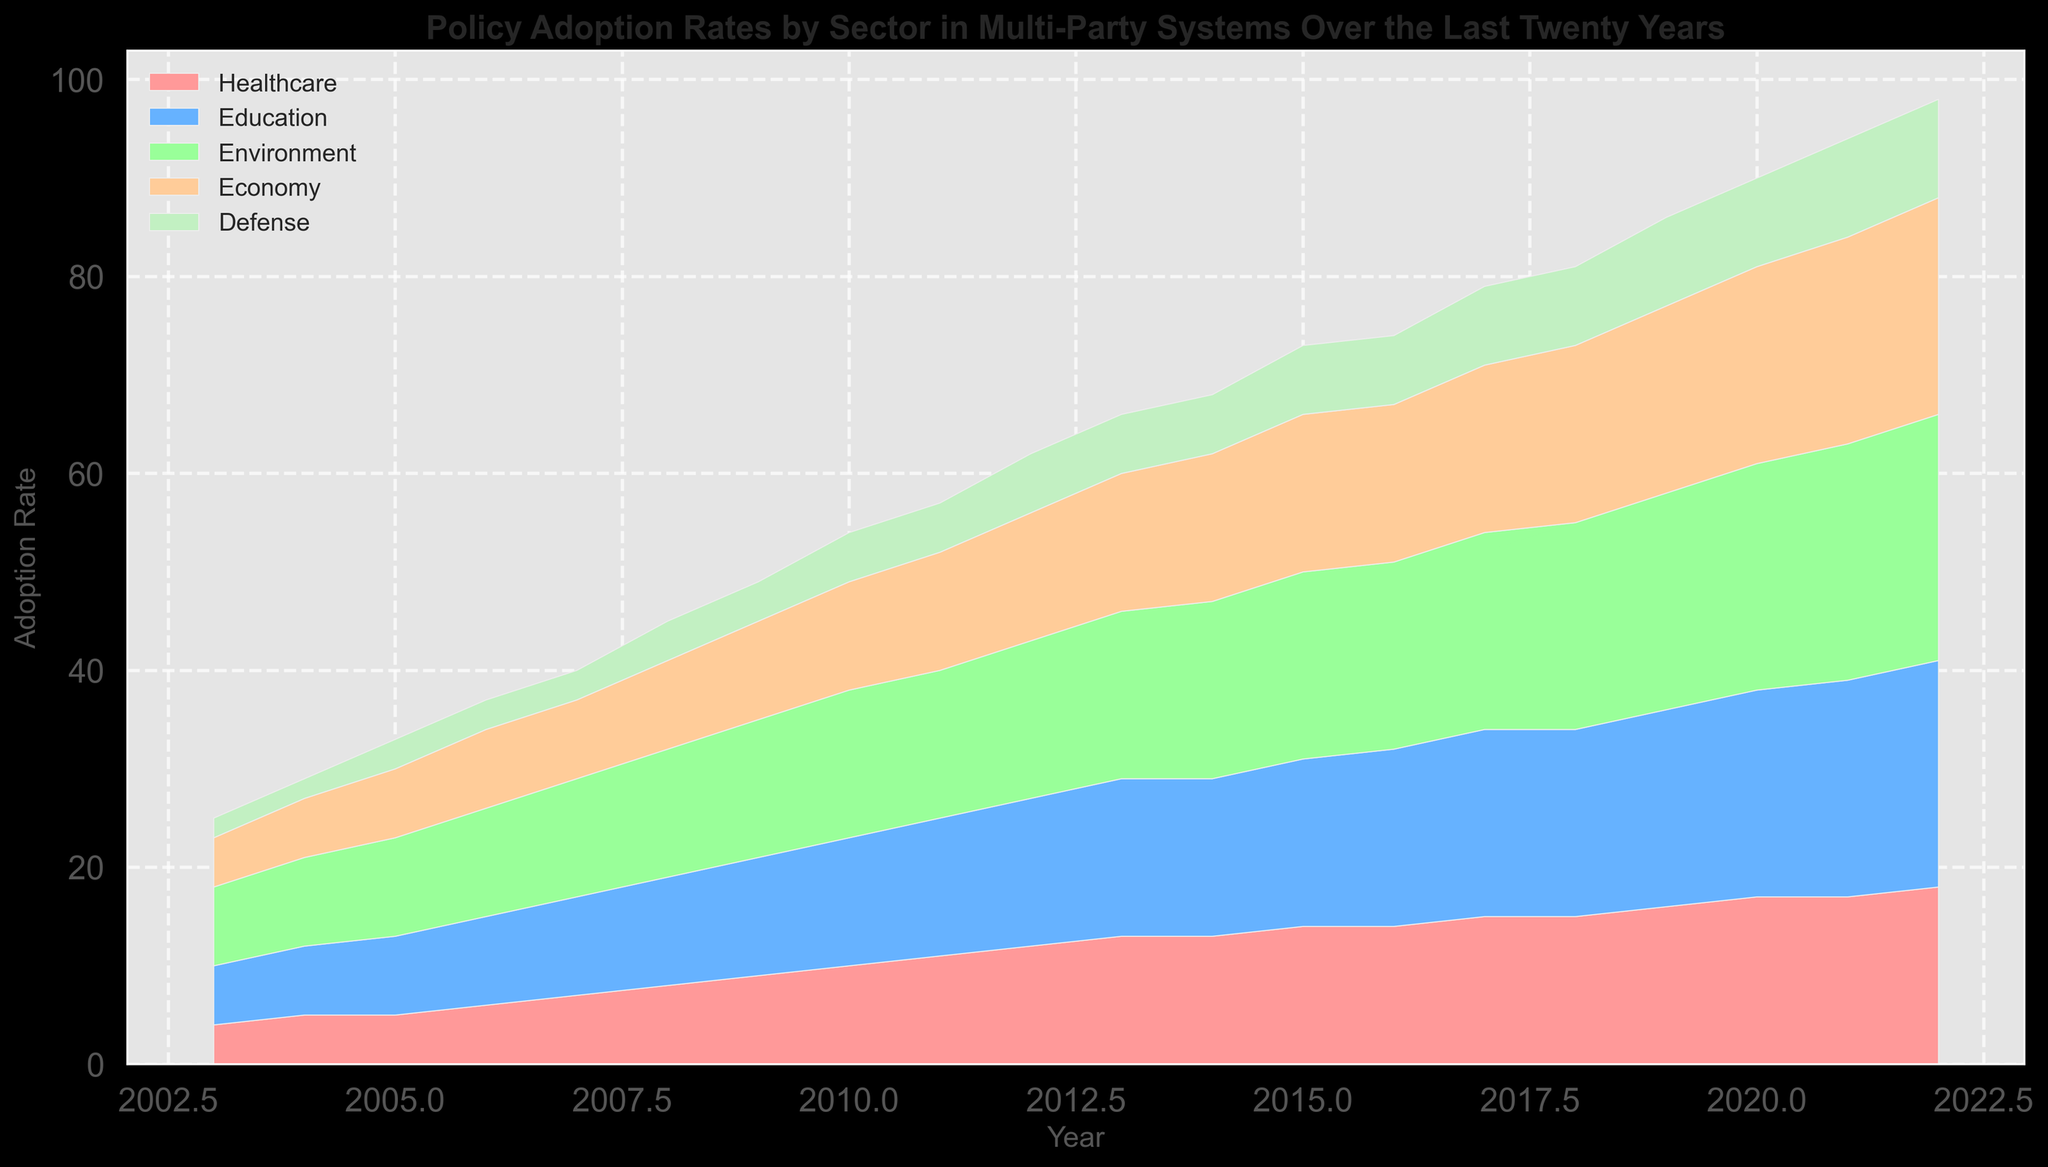What is the trend in policy adoption rates for the Healthcare sector over the last twenty years? By observing the area chart from 2003 to 2022, the adoption rate in the Healthcare sector shows a steady increase every year, starting from 4 and reaching 18 in 2022.
Answer: Steady increase Which sector had the highest adoption rate in 2018? By looking at the heights of the stacked areas for the year 2018, the topmost sector, which spans from 15 to 21, indicates that the Environment sector had the highest rate.
Answer: Environment Compare the adoption rates of Healthcare and Defense sectors in 2011. Which one is higher and by how much? In 2011, the Healthcare sector adoption rate is 11, and the Defense sector is at 5. Subtracting these, Healthcare is higher by 6.
Answer: Healthcare, by 6 What is the difference in the Economy sector's adoption rates between 2003 and 2022? The adoption rate for the Economy sector is 5 in 2003 and 22 in 2022. Subtracting these gives a difference of 17 (22 - 5).
Answer: 17 During which year did the Education and Environment sectors share the same adoption rate? By examining the chart, both the Education and the Environment sectors had an adoption rate of 16 in 2014.
Answer: 2014 Given the data, what is the average policy adoption rate for the Defense sector over the twenty years? Summing the Defense sector rates from 2003 to 2022 (2, 2, 3, 3, 3, 4, 4, 5, 5, 6, 6, 6, 7, 7, 8, 8, 9, 9, 10, 10) results in 103. Dividing by the number of years (20) gives 5.15.
Answer: 5.15 Which sector showed the smallest total change in policy adoption rate from 2003 to 2022? By calculating the change for each sector (Healthcare: 18 - 4 = 14, Education: 23 - 6 = 17, Environment: 25 - 8 = 17, Economy: 22 - 5 = 17, Defense: 10 - 2 = 8), Defense showed the smallest change of 8.
Answer: Defense What is the cumulative adoption rate for all sectors in 2020? Adding the adoption rates for all sectors in 2020: 17 (Healthcare) + 21 (Education) + 23 (Environment) + 20 (Economy) + 9 (Defense) results in 90.
Answer: 90 Between which consecutive years did the Economy sector experience the largest increase in policy adoption rate? By examining the chart and considering yearly differences, the largest increase is from 2019 to 2020, where the adoption rate increased from 19 to 20 by 1.
Answer: 2019 to 2020 